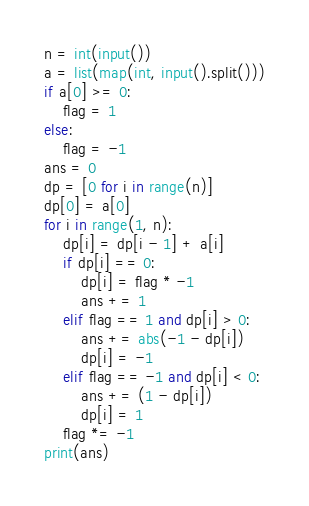<code> <loc_0><loc_0><loc_500><loc_500><_Python_>n = int(input())
a = list(map(int, input().split()))
if a[0] >= 0:
    flag = 1
else:
    flag = -1
ans = 0
dp = [0 for i in range(n)]
dp[0] = a[0]
for i in range(1, n):
    dp[i] = dp[i - 1] + a[i]
    if dp[i] == 0:
        dp[i] = flag * -1
        ans += 1
    elif flag == 1 and dp[i] > 0:
        ans += abs(-1 - dp[i])
        dp[i] = -1
    elif flag == -1 and dp[i] < 0:
        ans += (1 - dp[i])
        dp[i] = 1
    flag *= -1
print(ans)
</code> 